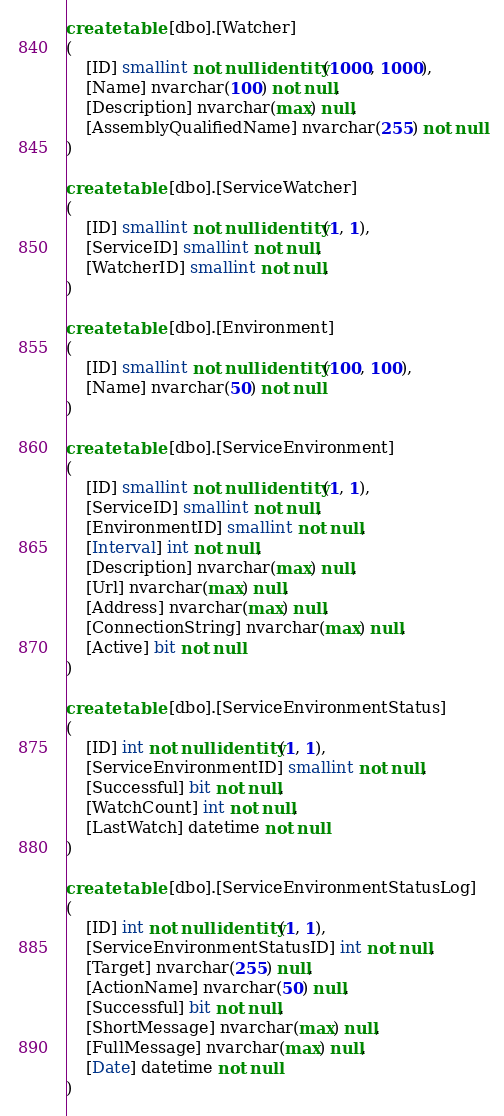Convert code to text. <code><loc_0><loc_0><loc_500><loc_500><_SQL_>
create table [dbo].[Watcher]
(
	[ID] smallint not null identity(1000, 1000),
	[Name] nvarchar(100) not null,
	[Description] nvarchar(max) null,
	[AssemblyQualifiedName] nvarchar(255) not null
)

create table [dbo].[ServiceWatcher]
(
	[ID] smallint not null identity(1, 1),
	[ServiceID] smallint not null,
	[WatcherID] smallint not null,
)

create table [dbo].[Environment]
(
	[ID] smallint not null identity(100, 100),
	[Name] nvarchar(50) not null
)

create table [dbo].[ServiceEnvironment]
(
	[ID] smallint not null identity(1, 1),
	[ServiceID] smallint not null,
	[EnvironmentID] smallint not null,
	[Interval] int not null,
	[Description] nvarchar(max) null,
	[Url] nvarchar(max) null,
	[Address] nvarchar(max) null,
	[ConnectionString] nvarchar(max) null,
	[Active] bit not null
)

create table [dbo].[ServiceEnvironmentStatus]
(
	[ID] int not null identity(1, 1),
	[ServiceEnvironmentID] smallint not null,
	[Successful] bit not null,
	[WatchCount] int not null,
	[LastWatch] datetime not null
)

create table [dbo].[ServiceEnvironmentStatusLog]
(
	[ID] int not null identity(1, 1),
	[ServiceEnvironmentStatusID] int not null,
	[Target] nvarchar(255) null,
	[ActionName] nvarchar(50) null,
	[Successful] bit not null,
	[ShortMessage] nvarchar(max) null,
	[FullMessage] nvarchar(max) null,
	[Date] datetime not null
)



</code> 